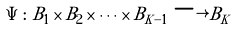<formula> <loc_0><loc_0><loc_500><loc_500>\Psi \colon B _ { 1 } \times B _ { 2 } \times \dots \times B _ { K - 1 } \longrightarrow B _ { K }</formula> 